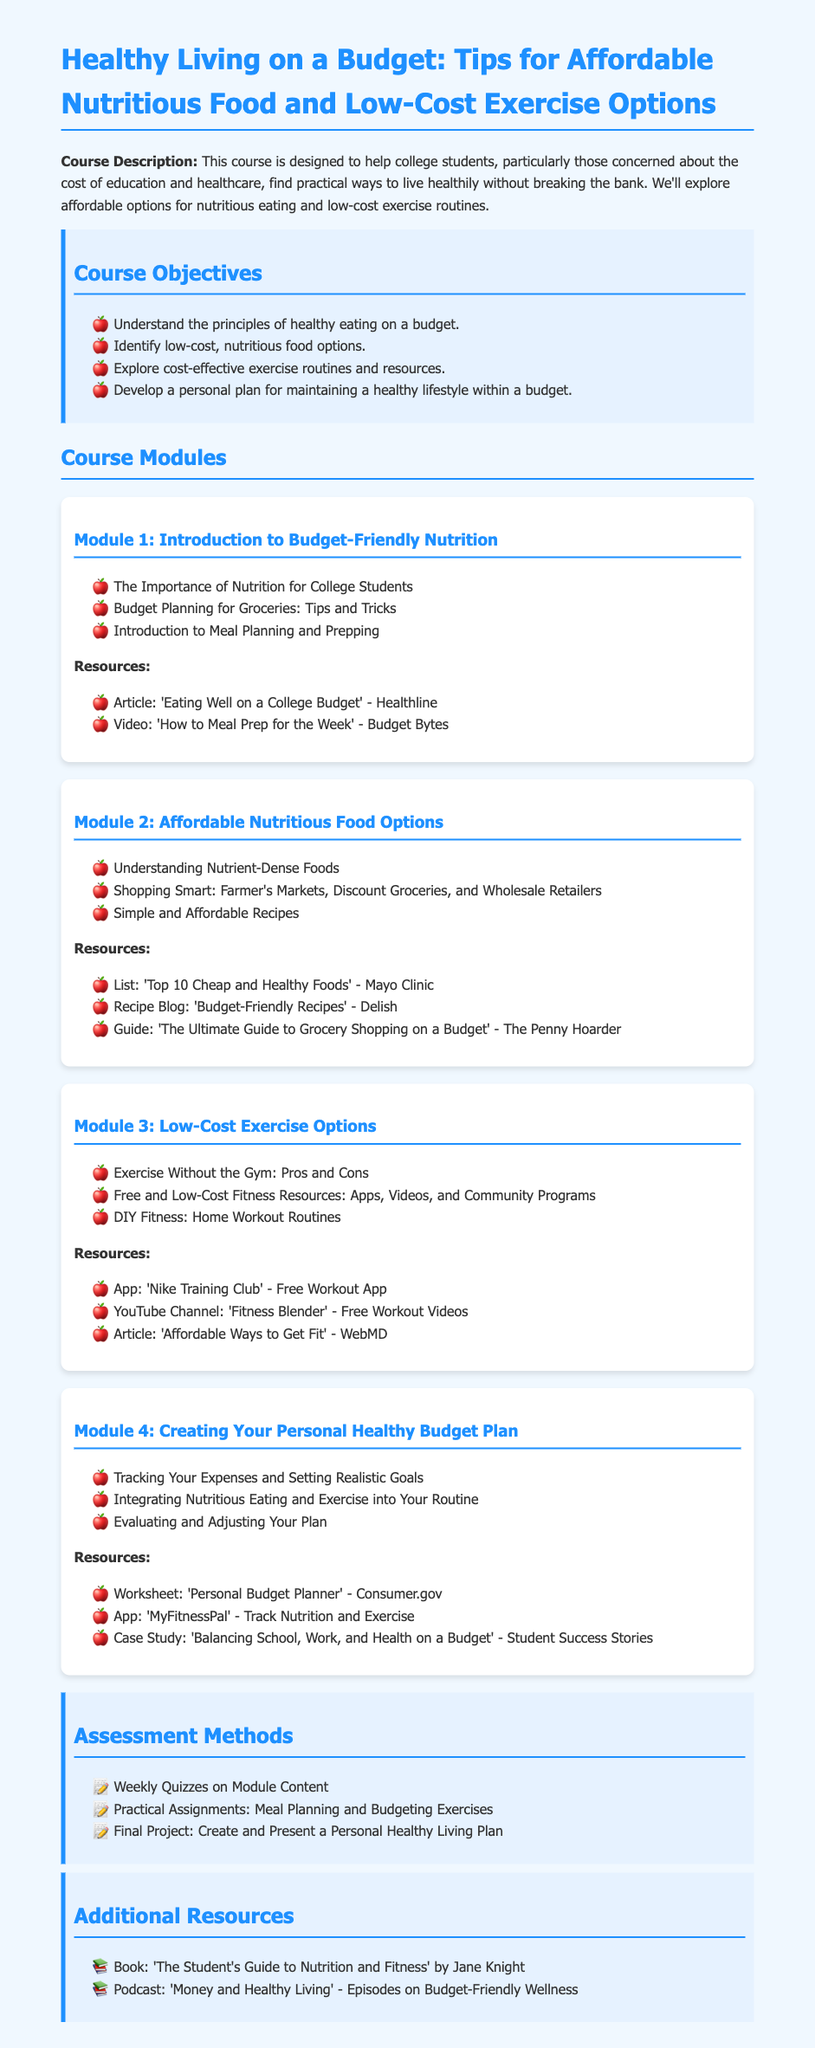What is the course title? The title of the course is provided at the beginning of the document, focusing on healthy living and budgeting.
Answer: Healthy Living on a Budget: Tips for Affordable Nutritious Food and Low-Cost Exercise Options What is one objective of the course? The course objectives outline specific educational goals, one of which is to promote understanding of healthy eating on a budget.
Answer: Understand the principles of healthy eating on a budget What is a low-cost exercise resource mentioned? The document lists various resources for low-cost exercise options, including an app that provides workouts.
Answer: Nike Training Club What is Module 2 about? The syllabus includes specific modules, with Module 2 focusing on affordable nutritious food options.
Answer: Affordable Nutritious Food Options How many modules are in the course? The document outlines the number of modules in the course by listing them after the course objectives.
Answer: Four What type of assessments are administered in the course? The assessment section details different evaluation methods used in the course, including practical assignments.
Answer: Practical Assignments: Meal Planning and Budgeting Exercises What is one resource related to budgeting? The resources section provides various tools, including worksheets related to budgeting for healthy living.
Answer: Personal Budget Planner What is the target audience for the course? The document highlights who the course is designed for, emphasizing college students concerned about education and healthcare costs.
Answer: College students What is a guide resource mentioned in Module 2? The syllabus specifies various resources provided in each module, including guides focused on grocery shopping on a budget.
Answer: The Ultimate Guide to Grocery Shopping on a Budget 